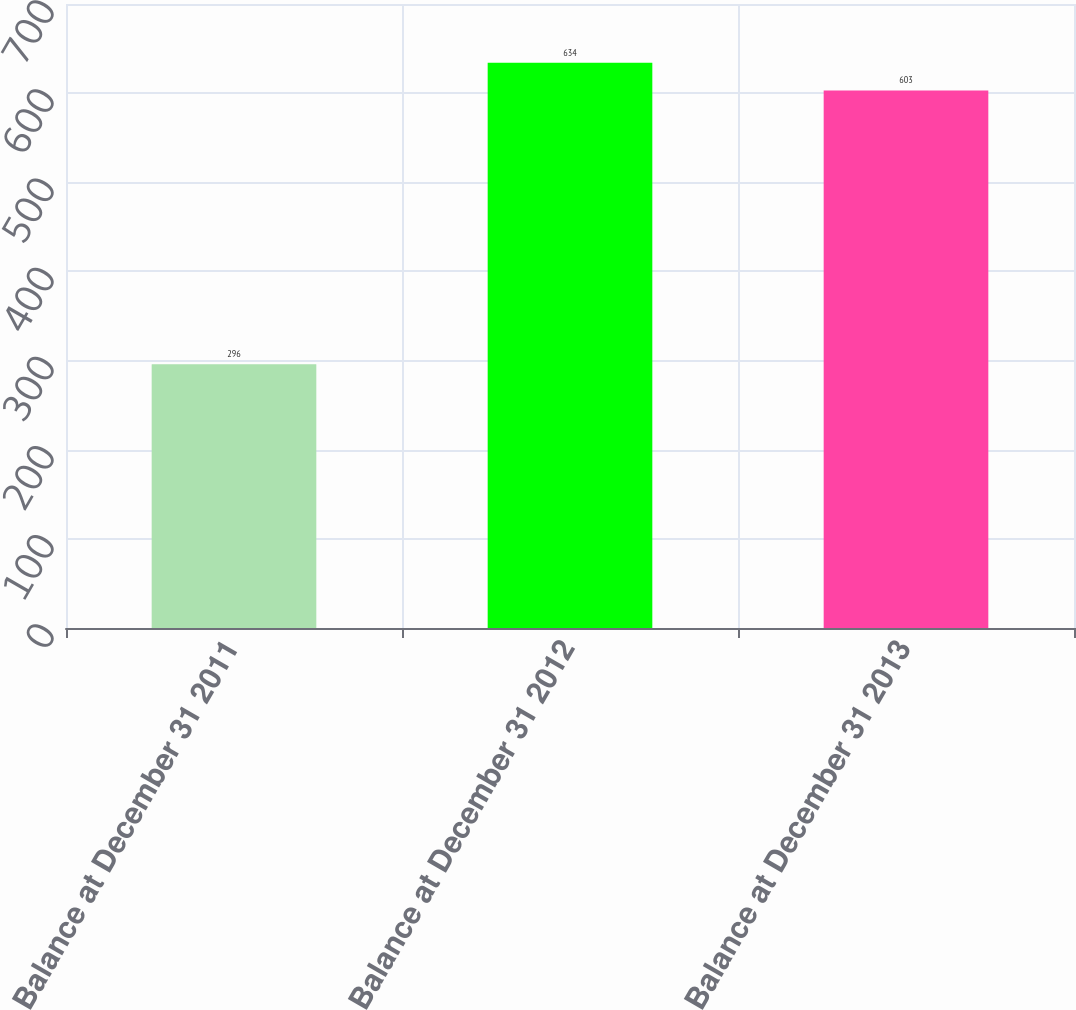<chart> <loc_0><loc_0><loc_500><loc_500><bar_chart><fcel>Balance at December 31 2011<fcel>Balance at December 31 2012<fcel>Balance at December 31 2013<nl><fcel>296<fcel>634<fcel>603<nl></chart> 